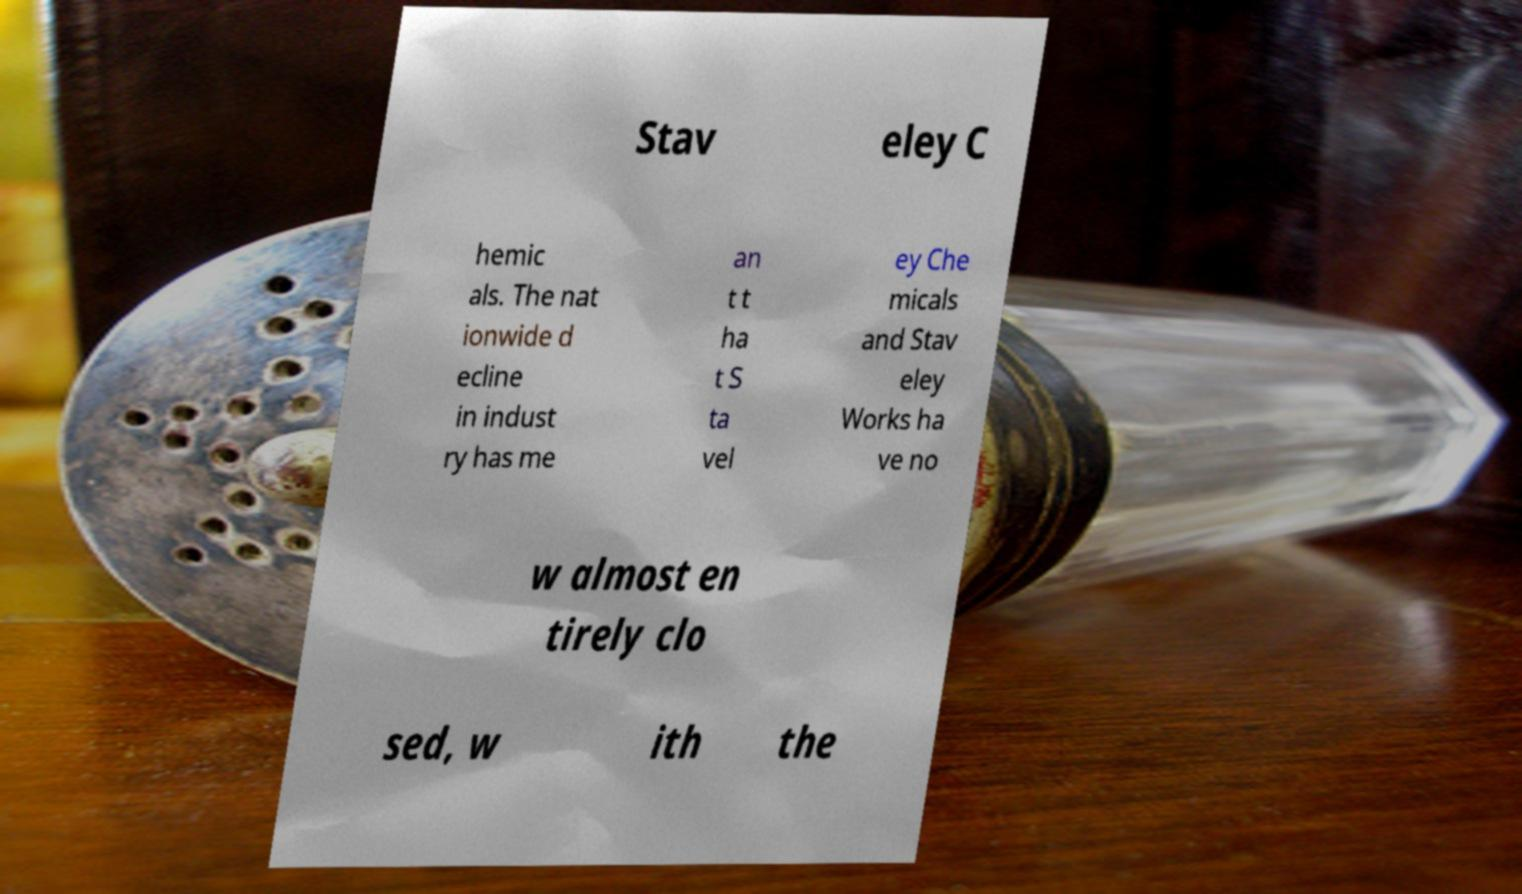Can you accurately transcribe the text from the provided image for me? Stav eley C hemic als. The nat ionwide d ecline in indust ry has me an t t ha t S ta vel ey Che micals and Stav eley Works ha ve no w almost en tirely clo sed, w ith the 